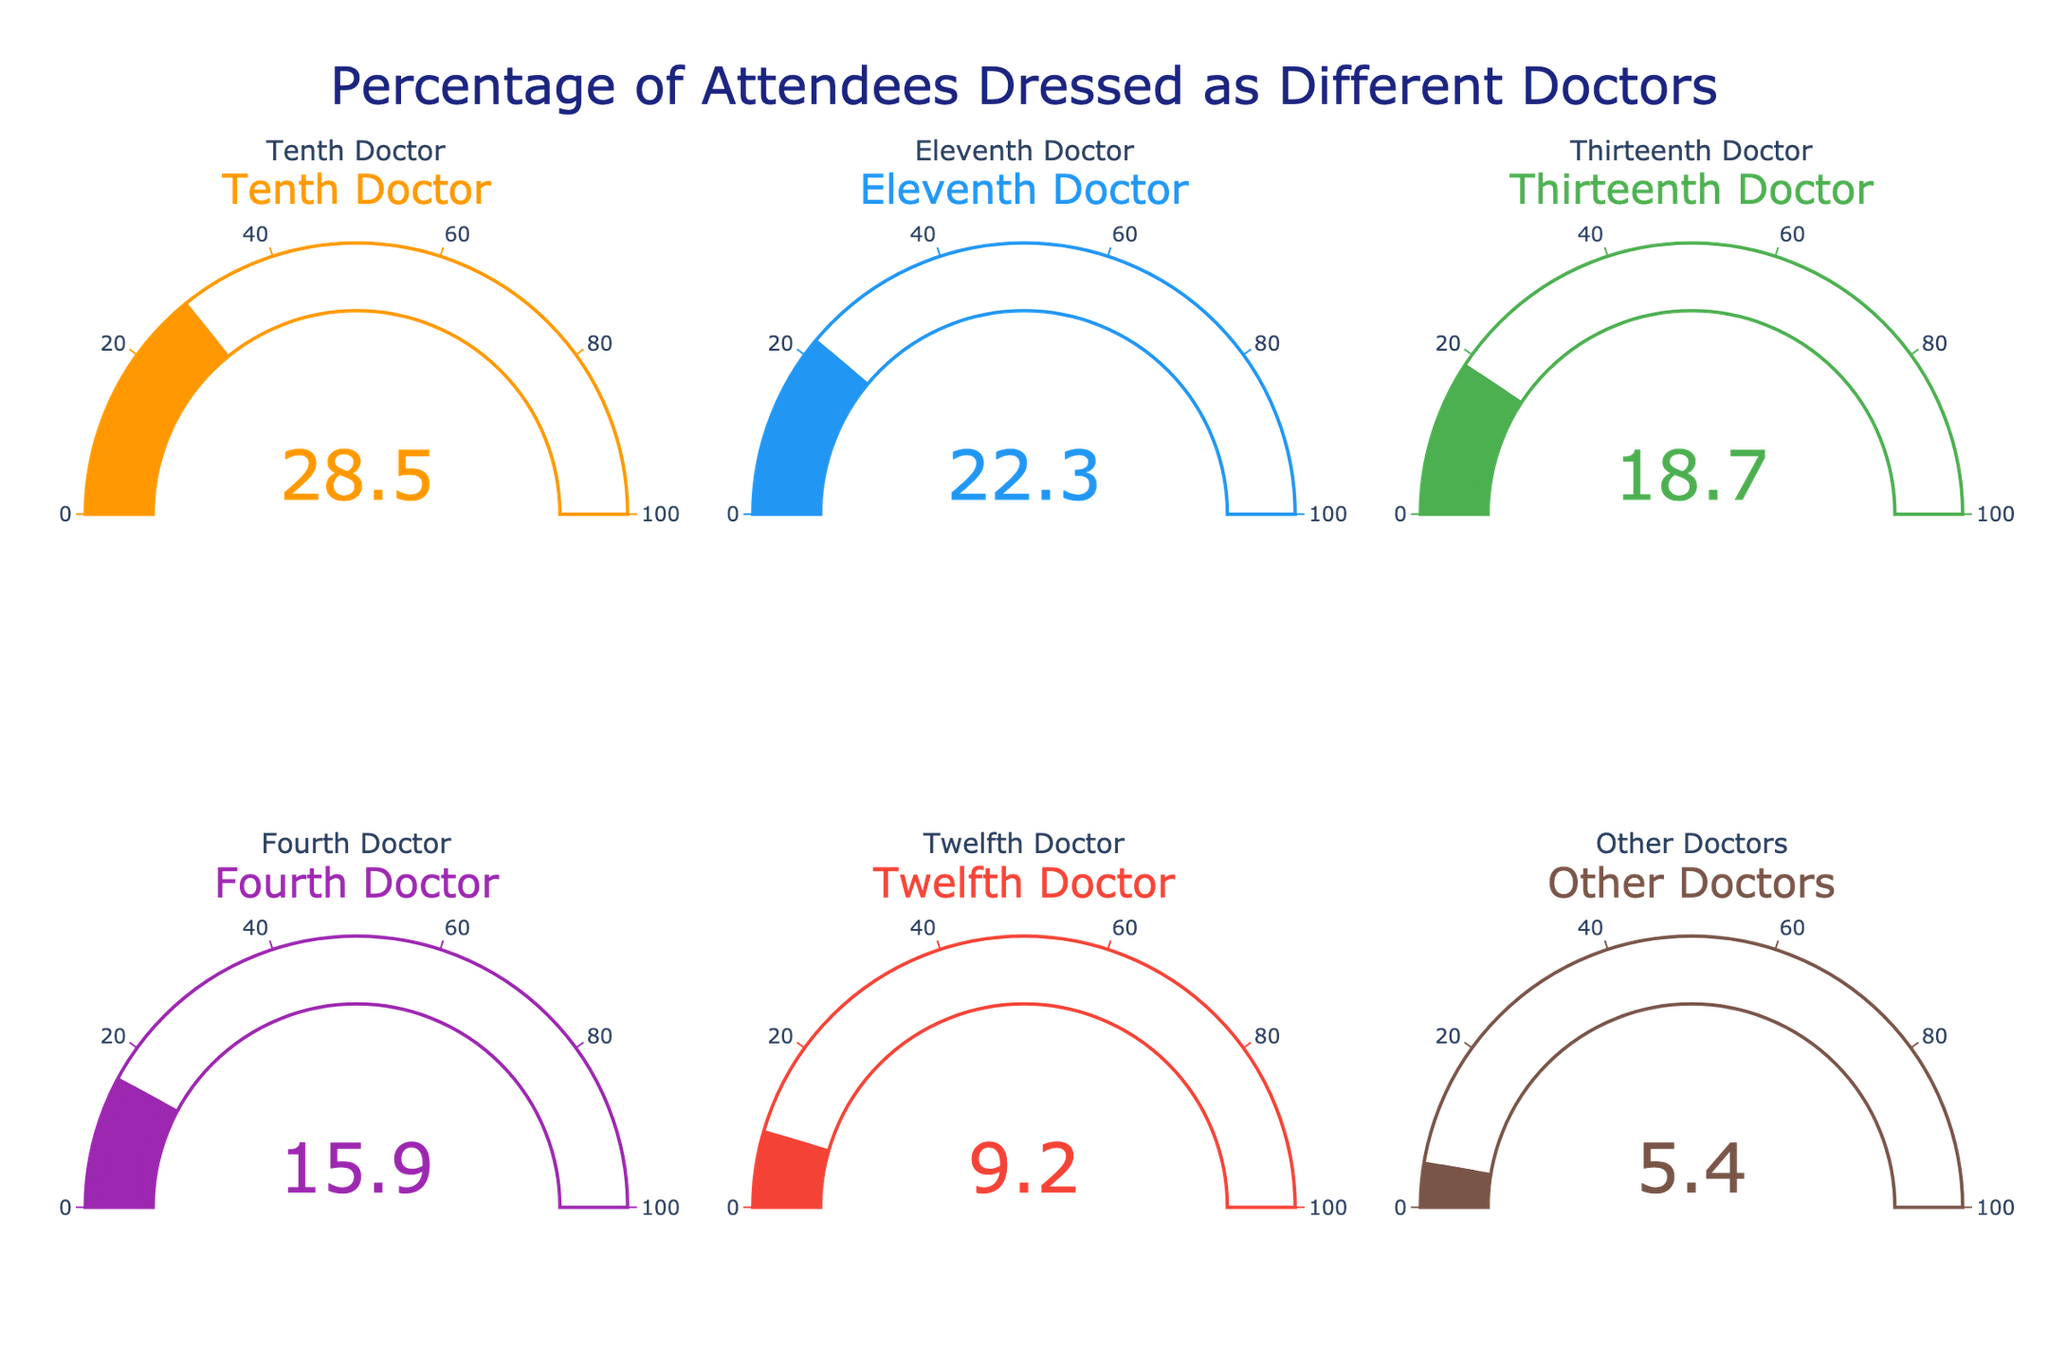What is the percentage of attendees dressed as the Twelfth Doctor? Look at the gauge labeled "Twelfth Doctor" and read the percentage value displayed on the gauge.
Answer: 9.2% Which Doctor has the highest percentage of attendees? Compare the percentage values displayed on all the gauges; the gauge with the highest percentage represents the Doctor with the highest percentage of attendees.
Answer: Tenth Doctor What is the combined percentage of attendees dressed as the Eleventh Doctor and the Thirteenth Doctor? Add the percentages displayed on the gauges for the Eleventh Doctor (22.3%) and the Thirteenth Doctor (18.7%).
Answer: 41.0% How much higher is the percentage of attendees dressed as the Tenth Doctor compared to the Fourth Doctor? Subtract the percentage value of the Fourth Doctor (15.9%) from the percentage value of the Tenth Doctor (28.5%).
Answer: 12.6% What is the average percentage of attendees dressed as any Doctor? Sum all the percentages and then divide by the number of Doctors represented (6). Sum is (28.5 + 22.3 + 18.7 + 15.9 + 9.2 + 5.4) = 100. Divide this sum by 6.
Answer: 16.67% Which Doctor has the lowest percentage of attendees? Compare the percentage values displayed on all the gauges and identify the gauge with the smallest percentage value.
Answer: Other Doctors Is the percentage of attendees dressed as the Eleventh Doctor greater than those dressed as the Thirteenth Doctor? Compare the values on the gauges labeled "Eleventh Doctor" and "Thirteenth Doctor". If the Eleventh Doctor's percentage (22.3%) is higher than the Thirteenth Doctor's percentage (18.7%), the answer is yes.
Answer: Yes What's the median percentage of attendees dressed as each Doctor? Organize the percentages in ascending order: 5.4, 9.2, 15.9, 18.7, 22.3, 28.5. The median value is the average of the middle two values (15.9 and 18.7).
Answer: 17.3% Which two unique Doctors have the closest percentages of attendees? Calculate the difference between each pair of Doctors and identify the smallest difference. The smallest difference is between the Twelfth Doctor (9.2%) and the Other Doctors (5.4%) = 3.8%.
Answer: Twelfth Doctor and Other Doctors 